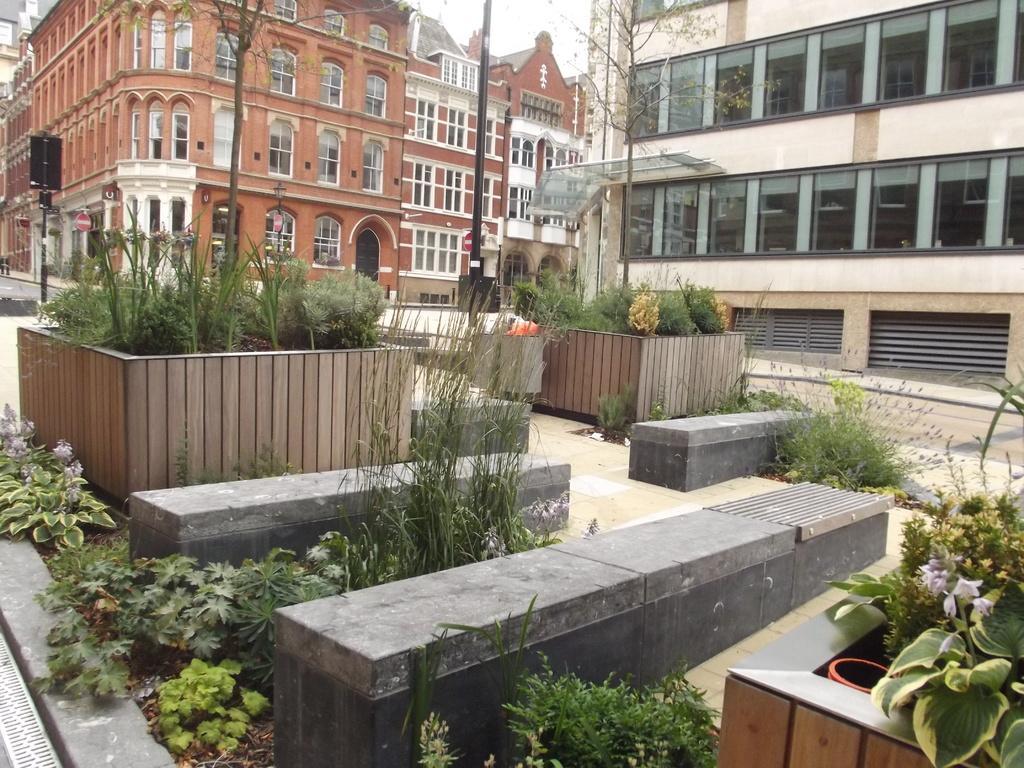How would you summarize this image in a sentence or two? In this picture we can see a beautiful view of the sitting area made of black stones. Behind there is a wooden block with some plants, In the background we can see brown color big building with white windows. On the right side we can see another building with glasses. 